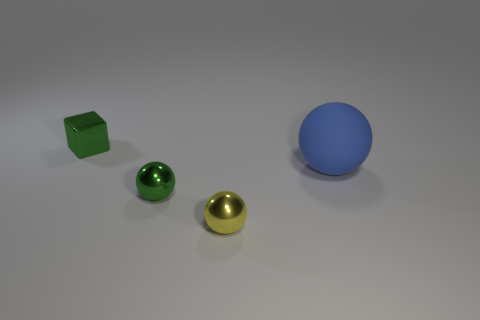The yellow object that is made of the same material as the small green cube is what shape? The yellow object shares the same glossy texture and reflective surface as the small green cube, indicating they are made of the same material. Observing its rounded appearance devoid of edges or vertices, it's clear that the yellow object is a sphere. 